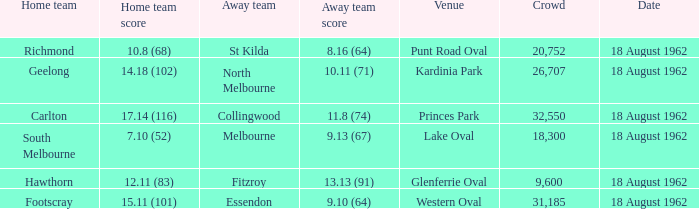At what venue where the home team scored 12.11 (83) was the crowd larger than 31,185? None. 